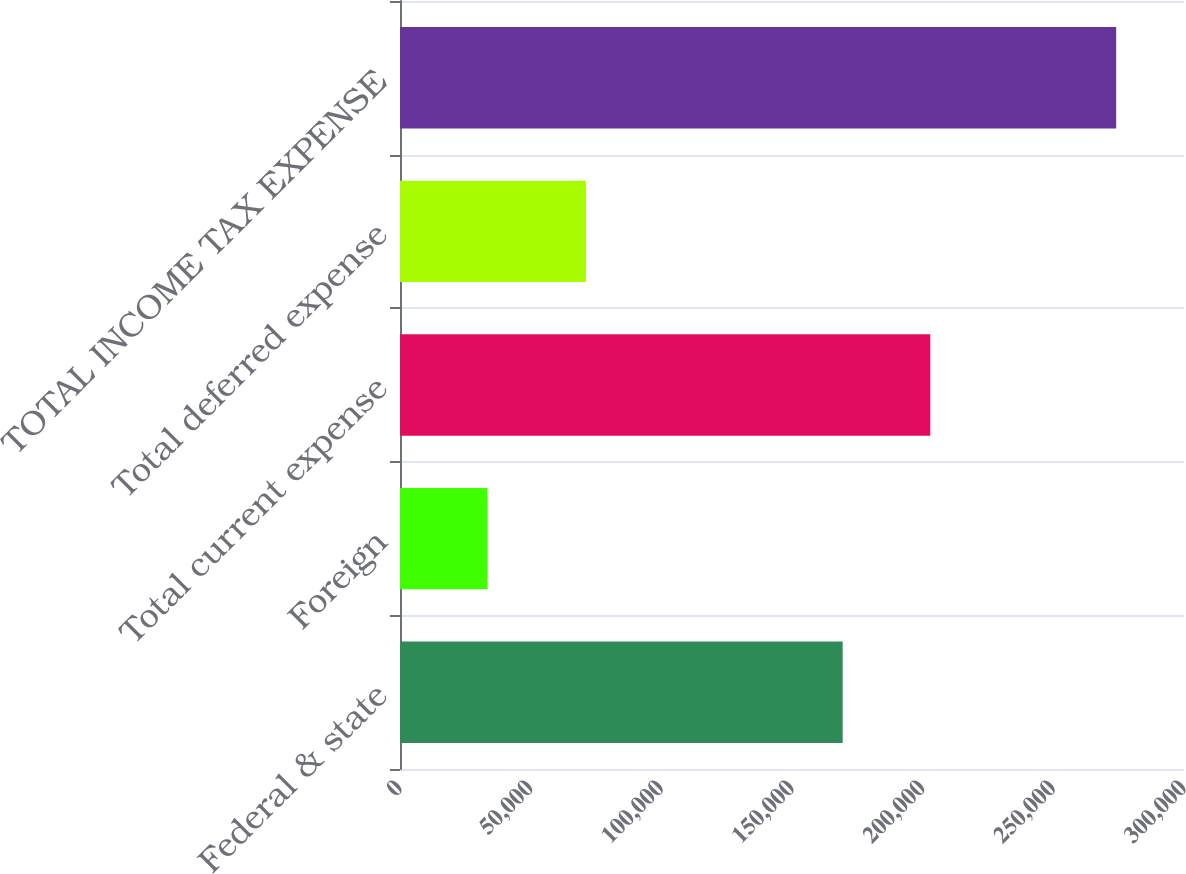Convert chart. <chart><loc_0><loc_0><loc_500><loc_500><bar_chart><fcel>Federal & state<fcel>Foreign<fcel>Total current expense<fcel>Total deferred expense<fcel>TOTAL INCOME TAX EXPENSE<nl><fcel>169394<fcel>33520<fcel>202914<fcel>71132<fcel>274046<nl></chart> 